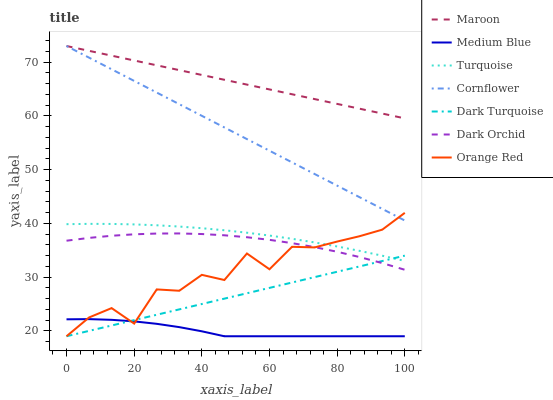Does Medium Blue have the minimum area under the curve?
Answer yes or no. Yes. Does Maroon have the maximum area under the curve?
Answer yes or no. Yes. Does Turquoise have the minimum area under the curve?
Answer yes or no. No. Does Turquoise have the maximum area under the curve?
Answer yes or no. No. Is Dark Turquoise the smoothest?
Answer yes or no. Yes. Is Orange Red the roughest?
Answer yes or no. Yes. Is Turquoise the smoothest?
Answer yes or no. No. Is Turquoise the roughest?
Answer yes or no. No. Does Dark Turquoise have the lowest value?
Answer yes or no. Yes. Does Turquoise have the lowest value?
Answer yes or no. No. Does Maroon have the highest value?
Answer yes or no. Yes. Does Turquoise have the highest value?
Answer yes or no. No. Is Dark Orchid less than Maroon?
Answer yes or no. Yes. Is Cornflower greater than Medium Blue?
Answer yes or no. Yes. Does Orange Red intersect Dark Turquoise?
Answer yes or no. Yes. Is Orange Red less than Dark Turquoise?
Answer yes or no. No. Is Orange Red greater than Dark Turquoise?
Answer yes or no. No. Does Dark Orchid intersect Maroon?
Answer yes or no. No. 